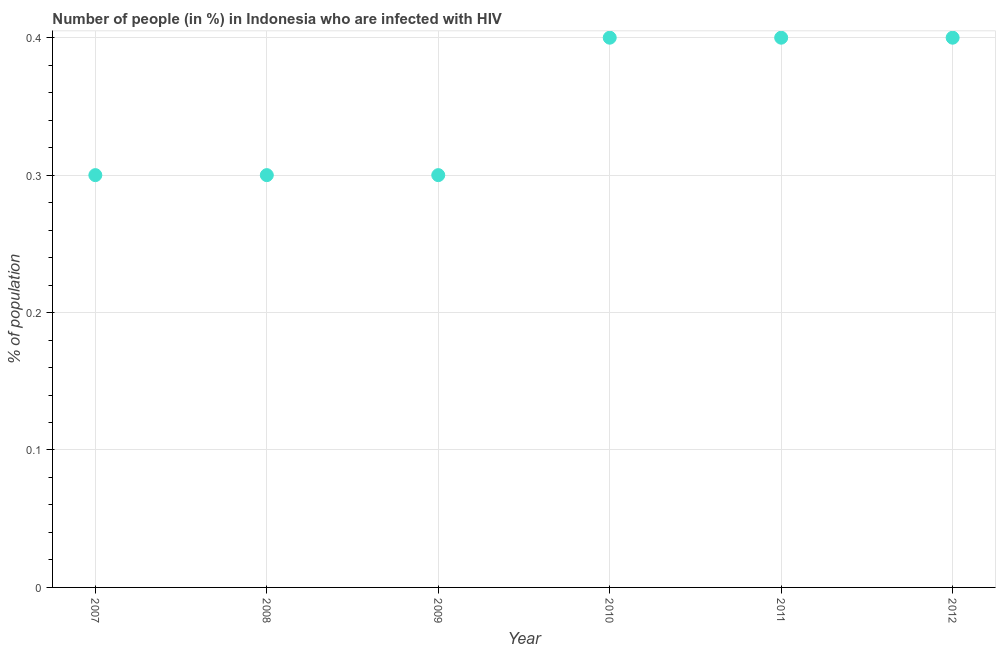Across all years, what is the minimum number of people infected with hiv?
Keep it short and to the point. 0.3. In which year was the number of people infected with hiv maximum?
Make the answer very short. 2010. In which year was the number of people infected with hiv minimum?
Offer a very short reply. 2007. What is the sum of the number of people infected with hiv?
Ensure brevity in your answer.  2.1. What is the difference between the number of people infected with hiv in 2009 and 2011?
Your response must be concise. -0.1. What is the average number of people infected with hiv per year?
Provide a succinct answer. 0.35. In how many years, is the number of people infected with hiv greater than 0.28 %?
Your response must be concise. 6. Do a majority of the years between 2011 and 2008 (inclusive) have number of people infected with hiv greater than 0.02 %?
Offer a very short reply. Yes. What is the ratio of the number of people infected with hiv in 2007 to that in 2009?
Provide a succinct answer. 1. Is the number of people infected with hiv in 2008 less than that in 2009?
Make the answer very short. No. What is the difference between the highest and the second highest number of people infected with hiv?
Provide a short and direct response. 0. What is the difference between the highest and the lowest number of people infected with hiv?
Make the answer very short. 0.1. In how many years, is the number of people infected with hiv greater than the average number of people infected with hiv taken over all years?
Give a very brief answer. 3. Does the number of people infected with hiv monotonically increase over the years?
Offer a very short reply. No. How many dotlines are there?
Your answer should be very brief. 1. How many years are there in the graph?
Offer a terse response. 6. What is the difference between two consecutive major ticks on the Y-axis?
Give a very brief answer. 0.1. Does the graph contain any zero values?
Keep it short and to the point. No. Does the graph contain grids?
Your response must be concise. Yes. What is the title of the graph?
Keep it short and to the point. Number of people (in %) in Indonesia who are infected with HIV. What is the label or title of the X-axis?
Make the answer very short. Year. What is the label or title of the Y-axis?
Provide a short and direct response. % of population. What is the % of population in 2007?
Give a very brief answer. 0.3. What is the % of population in 2009?
Give a very brief answer. 0.3. What is the % of population in 2010?
Make the answer very short. 0.4. What is the % of population in 2012?
Offer a very short reply. 0.4. What is the difference between the % of population in 2007 and 2008?
Make the answer very short. 0. What is the difference between the % of population in 2007 and 2010?
Make the answer very short. -0.1. What is the difference between the % of population in 2007 and 2011?
Your answer should be very brief. -0.1. What is the difference between the % of population in 2007 and 2012?
Ensure brevity in your answer.  -0.1. What is the difference between the % of population in 2008 and 2010?
Offer a terse response. -0.1. What is the difference between the % of population in 2008 and 2012?
Give a very brief answer. -0.1. What is the difference between the % of population in 2009 and 2011?
Provide a succinct answer. -0.1. What is the difference between the % of population in 2009 and 2012?
Your answer should be compact. -0.1. What is the difference between the % of population in 2010 and 2012?
Offer a very short reply. 0. What is the ratio of the % of population in 2007 to that in 2008?
Offer a terse response. 1. What is the ratio of the % of population in 2007 to that in 2009?
Give a very brief answer. 1. What is the ratio of the % of population in 2007 to that in 2010?
Your answer should be compact. 0.75. What is the ratio of the % of population in 2007 to that in 2011?
Ensure brevity in your answer.  0.75. What is the ratio of the % of population in 2008 to that in 2009?
Your response must be concise. 1. What is the ratio of the % of population in 2009 to that in 2010?
Your answer should be compact. 0.75. What is the ratio of the % of population in 2009 to that in 2012?
Provide a succinct answer. 0.75. What is the ratio of the % of population in 2010 to that in 2011?
Make the answer very short. 1. What is the ratio of the % of population in 2010 to that in 2012?
Make the answer very short. 1. What is the ratio of the % of population in 2011 to that in 2012?
Offer a terse response. 1. 